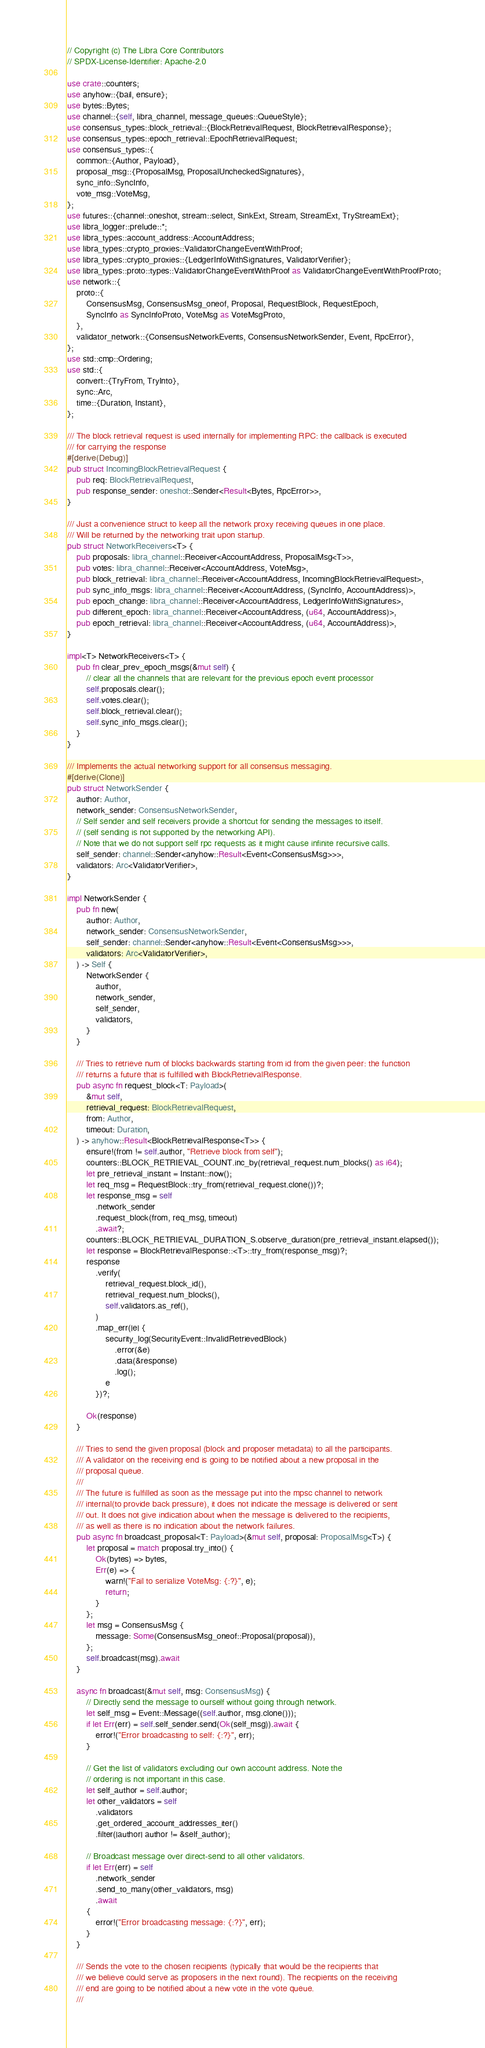Convert code to text. <code><loc_0><loc_0><loc_500><loc_500><_Rust_>// Copyright (c) The Libra Core Contributors
// SPDX-License-Identifier: Apache-2.0

use crate::counters;
use anyhow::{bail, ensure};
use bytes::Bytes;
use channel::{self, libra_channel, message_queues::QueueStyle};
use consensus_types::block_retrieval::{BlockRetrievalRequest, BlockRetrievalResponse};
use consensus_types::epoch_retrieval::EpochRetrievalRequest;
use consensus_types::{
    common::{Author, Payload},
    proposal_msg::{ProposalMsg, ProposalUncheckedSignatures},
    sync_info::SyncInfo,
    vote_msg::VoteMsg,
};
use futures::{channel::oneshot, stream::select, SinkExt, Stream, StreamExt, TryStreamExt};
use libra_logger::prelude::*;
use libra_types::account_address::AccountAddress;
use libra_types::crypto_proxies::ValidatorChangeEventWithProof;
use libra_types::crypto_proxies::{LedgerInfoWithSignatures, ValidatorVerifier};
use libra_types::proto::types::ValidatorChangeEventWithProof as ValidatorChangeEventWithProofProto;
use network::{
    proto::{
        ConsensusMsg, ConsensusMsg_oneof, Proposal, RequestBlock, RequestEpoch,
        SyncInfo as SyncInfoProto, VoteMsg as VoteMsgProto,
    },
    validator_network::{ConsensusNetworkEvents, ConsensusNetworkSender, Event, RpcError},
};
use std::cmp::Ordering;
use std::{
    convert::{TryFrom, TryInto},
    sync::Arc,
    time::{Duration, Instant},
};

/// The block retrieval request is used internally for implementing RPC: the callback is executed
/// for carrying the response
#[derive(Debug)]
pub struct IncomingBlockRetrievalRequest {
    pub req: BlockRetrievalRequest,
    pub response_sender: oneshot::Sender<Result<Bytes, RpcError>>,
}

/// Just a convenience struct to keep all the network proxy receiving queues in one place.
/// Will be returned by the networking trait upon startup.
pub struct NetworkReceivers<T> {
    pub proposals: libra_channel::Receiver<AccountAddress, ProposalMsg<T>>,
    pub votes: libra_channel::Receiver<AccountAddress, VoteMsg>,
    pub block_retrieval: libra_channel::Receiver<AccountAddress, IncomingBlockRetrievalRequest>,
    pub sync_info_msgs: libra_channel::Receiver<AccountAddress, (SyncInfo, AccountAddress)>,
    pub epoch_change: libra_channel::Receiver<AccountAddress, LedgerInfoWithSignatures>,
    pub different_epoch: libra_channel::Receiver<AccountAddress, (u64, AccountAddress)>,
    pub epoch_retrieval: libra_channel::Receiver<AccountAddress, (u64, AccountAddress)>,
}

impl<T> NetworkReceivers<T> {
    pub fn clear_prev_epoch_msgs(&mut self) {
        // clear all the channels that are relevant for the previous epoch event processor
        self.proposals.clear();
        self.votes.clear();
        self.block_retrieval.clear();
        self.sync_info_msgs.clear();
    }
}

/// Implements the actual networking support for all consensus messaging.
#[derive(Clone)]
pub struct NetworkSender {
    author: Author,
    network_sender: ConsensusNetworkSender,
    // Self sender and self receivers provide a shortcut for sending the messages to itself.
    // (self sending is not supported by the networking API).
    // Note that we do not support self rpc requests as it might cause infinite recursive calls.
    self_sender: channel::Sender<anyhow::Result<Event<ConsensusMsg>>>,
    validators: Arc<ValidatorVerifier>,
}

impl NetworkSender {
    pub fn new(
        author: Author,
        network_sender: ConsensusNetworkSender,
        self_sender: channel::Sender<anyhow::Result<Event<ConsensusMsg>>>,
        validators: Arc<ValidatorVerifier>,
    ) -> Self {
        NetworkSender {
            author,
            network_sender,
            self_sender,
            validators,
        }
    }

    /// Tries to retrieve num of blocks backwards starting from id from the given peer: the function
    /// returns a future that is fulfilled with BlockRetrievalResponse.
    pub async fn request_block<T: Payload>(
        &mut self,
        retrieval_request: BlockRetrievalRequest,
        from: Author,
        timeout: Duration,
    ) -> anyhow::Result<BlockRetrievalResponse<T>> {
        ensure!(from != self.author, "Retrieve block from self");
        counters::BLOCK_RETRIEVAL_COUNT.inc_by(retrieval_request.num_blocks() as i64);
        let pre_retrieval_instant = Instant::now();
        let req_msg = RequestBlock::try_from(retrieval_request.clone())?;
        let response_msg = self
            .network_sender
            .request_block(from, req_msg, timeout)
            .await?;
        counters::BLOCK_RETRIEVAL_DURATION_S.observe_duration(pre_retrieval_instant.elapsed());
        let response = BlockRetrievalResponse::<T>::try_from(response_msg)?;
        response
            .verify(
                retrieval_request.block_id(),
                retrieval_request.num_blocks(),
                self.validators.as_ref(),
            )
            .map_err(|e| {
                security_log(SecurityEvent::InvalidRetrievedBlock)
                    .error(&e)
                    .data(&response)
                    .log();
                e
            })?;

        Ok(response)
    }

    /// Tries to send the given proposal (block and proposer metadata) to all the participants.
    /// A validator on the receiving end is going to be notified about a new proposal in the
    /// proposal queue.
    ///
    /// The future is fulfilled as soon as the message put into the mpsc channel to network
    /// internal(to provide back pressure), it does not indicate the message is delivered or sent
    /// out. It does not give indication about when the message is delivered to the recipients,
    /// as well as there is no indication about the network failures.
    pub async fn broadcast_proposal<T: Payload>(&mut self, proposal: ProposalMsg<T>) {
        let proposal = match proposal.try_into() {
            Ok(bytes) => bytes,
            Err(e) => {
                warn!("Fail to serialize VoteMsg: {:?}", e);
                return;
            }
        };
        let msg = ConsensusMsg {
            message: Some(ConsensusMsg_oneof::Proposal(proposal)),
        };
        self.broadcast(msg).await
    }

    async fn broadcast(&mut self, msg: ConsensusMsg) {
        // Directly send the message to ourself without going through network.
        let self_msg = Event::Message((self.author, msg.clone()));
        if let Err(err) = self.self_sender.send(Ok(self_msg)).await {
            error!("Error broadcasting to self: {:?}", err);
        }

        // Get the list of validators excluding our own account address. Note the
        // ordering is not important in this case.
        let self_author = self.author;
        let other_validators = self
            .validators
            .get_ordered_account_addresses_iter()
            .filter(|author| author != &self_author);

        // Broadcast message over direct-send to all other validators.
        if let Err(err) = self
            .network_sender
            .send_to_many(other_validators, msg)
            .await
        {
            error!("Error broadcasting message: {:?}", err);
        }
    }

    /// Sends the vote to the chosen recipients (typically that would be the recipients that
    /// we believe could serve as proposers in the next round). The recipients on the receiving
    /// end are going to be notified about a new vote in the vote queue.
    ///</code> 